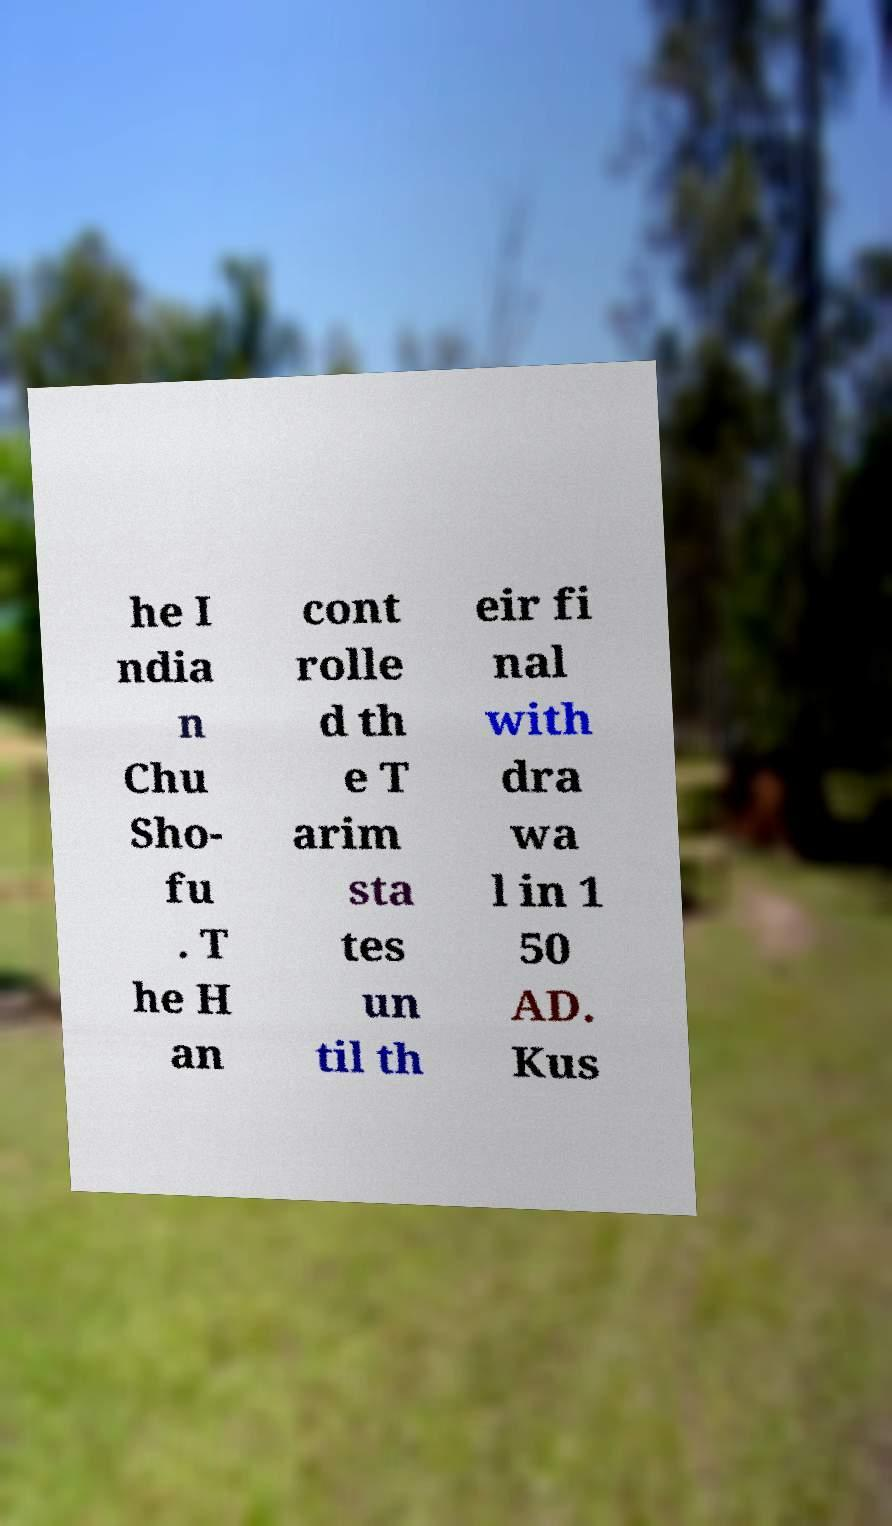Please read and relay the text visible in this image. What does it say? he I ndia n Chu Sho- fu . T he H an cont rolle d th e T arim sta tes un til th eir fi nal with dra wa l in 1 50 AD. Kus 